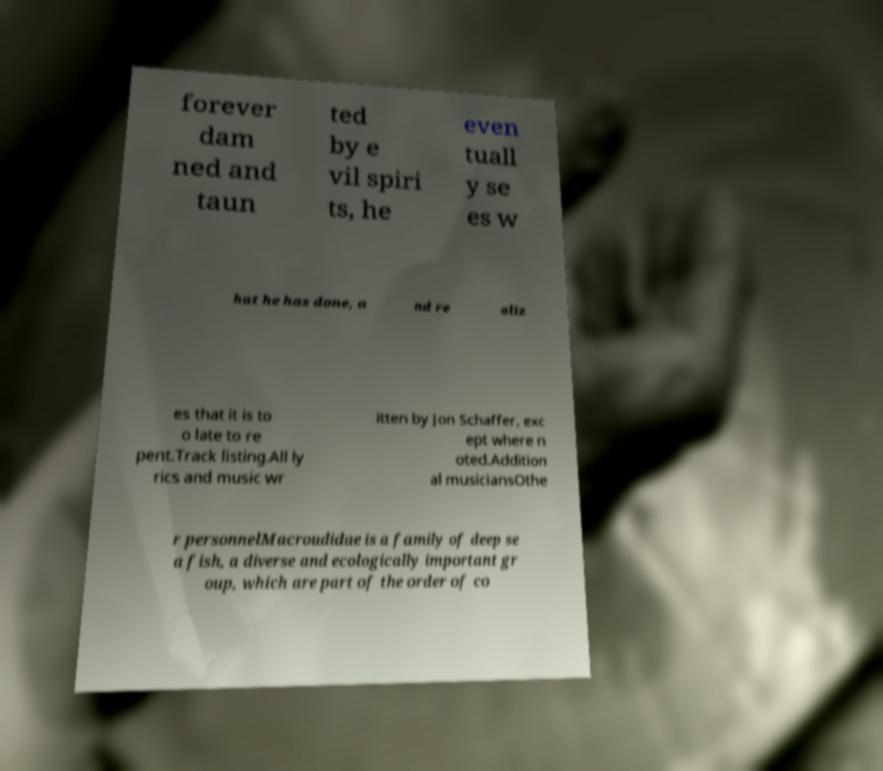Please read and relay the text visible in this image. What does it say? forever dam ned and taun ted by e vil spiri ts, he even tuall y se es w hat he has done, a nd re aliz es that it is to o late to re pent.Track listing.All ly rics and music wr itten by Jon Schaffer, exc ept where n oted.Addition al musiciansOthe r personnelMacroudidae is a family of deep se a fish, a diverse and ecologically important gr oup, which are part of the order of co 